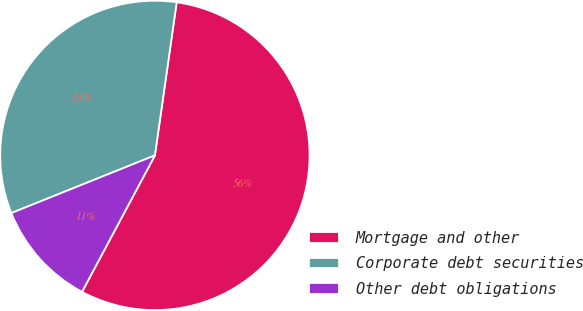Convert chart to OTSL. <chart><loc_0><loc_0><loc_500><loc_500><pie_chart><fcel>Mortgage and other<fcel>Corporate debt securities<fcel>Other debt obligations<nl><fcel>55.56%<fcel>33.33%<fcel>11.11%<nl></chart> 